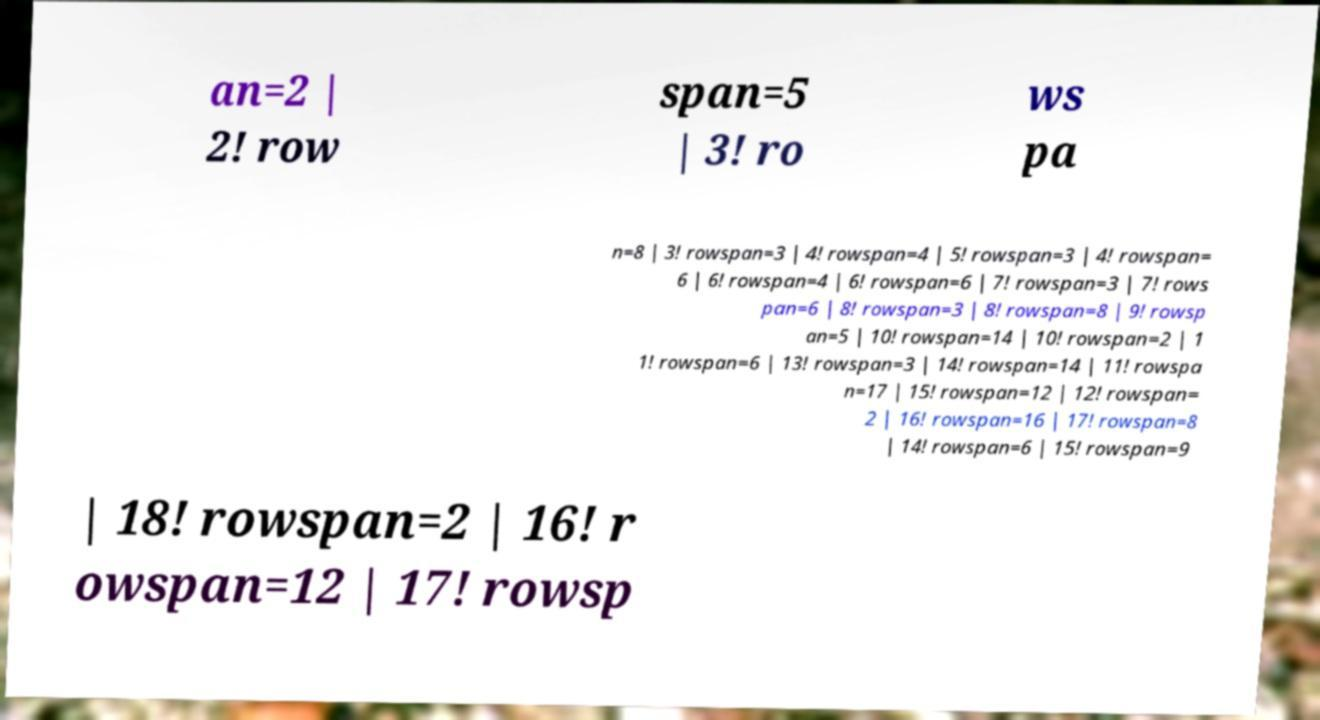Please read and relay the text visible in this image. What does it say? an=2 | 2! row span=5 | 3! ro ws pa n=8 | 3! rowspan=3 | 4! rowspan=4 | 5! rowspan=3 | 4! rowspan= 6 | 6! rowspan=4 | 6! rowspan=6 | 7! rowspan=3 | 7! rows pan=6 | 8! rowspan=3 | 8! rowspan=8 | 9! rowsp an=5 | 10! rowspan=14 | 10! rowspan=2 | 1 1! rowspan=6 | 13! rowspan=3 | 14! rowspan=14 | 11! rowspa n=17 | 15! rowspan=12 | 12! rowspan= 2 | 16! rowspan=16 | 17! rowspan=8 | 14! rowspan=6 | 15! rowspan=9 | 18! rowspan=2 | 16! r owspan=12 | 17! rowsp 